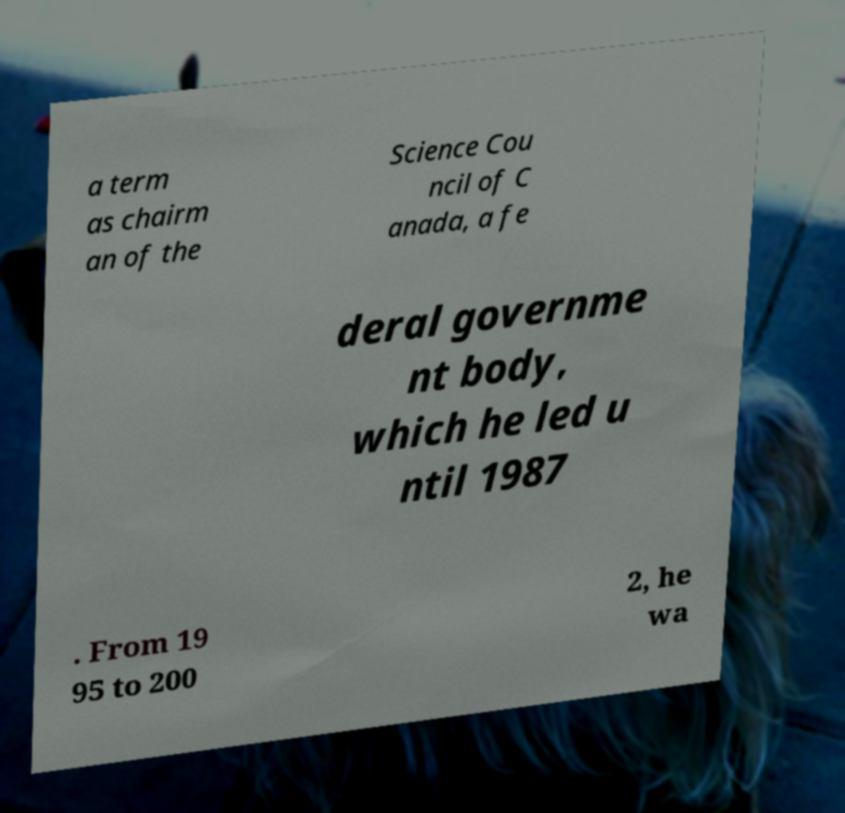Can you accurately transcribe the text from the provided image for me? a term as chairm an of the Science Cou ncil of C anada, a fe deral governme nt body, which he led u ntil 1987 . From 19 95 to 200 2, he wa 